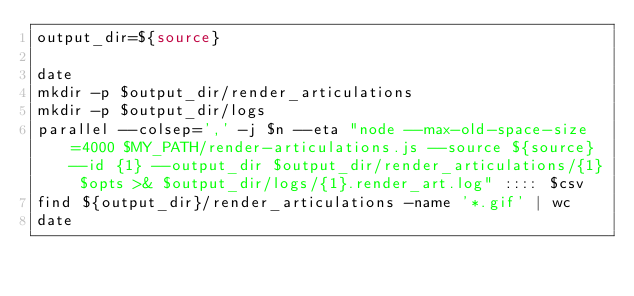Convert code to text. <code><loc_0><loc_0><loc_500><loc_500><_Bash_>output_dir=${source}

date
mkdir -p $output_dir/render_articulations
mkdir -p $output_dir/logs
parallel --colsep=',' -j $n --eta "node --max-old-space-size=4000 $MY_PATH/render-articulations.js --source ${source} --id {1} --output_dir $output_dir/render_articulations/{1} $opts >& $output_dir/logs/{1}.render_art.log" :::: $csv
find ${output_dir}/render_articulations -name '*.gif' | wc
date</code> 